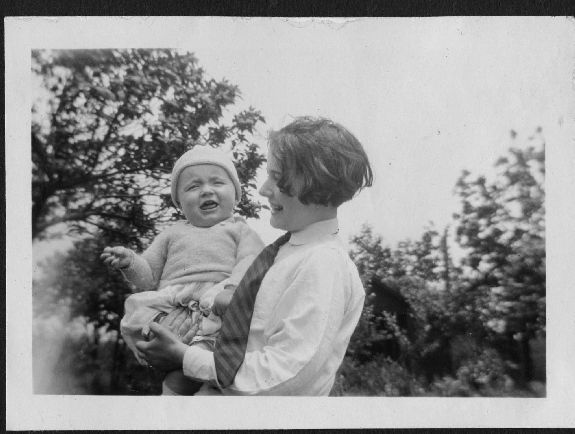<image>What kind of chair is the baby sitting in? The baby is not sitting in any kind of chair according to the information provided. What pattern are the boys pants? I am not sure, the pattern of the boy's pants could be plain, striped or solid. What pattern are the boys pants? I don't know what pattern the boys pants have. It can be solid, plain, striped or none. What kind of chair is the baby sitting in? I am not sure what kind of chair the baby is sitting in. It can be a high chair or it may not be sitting in any chair. 